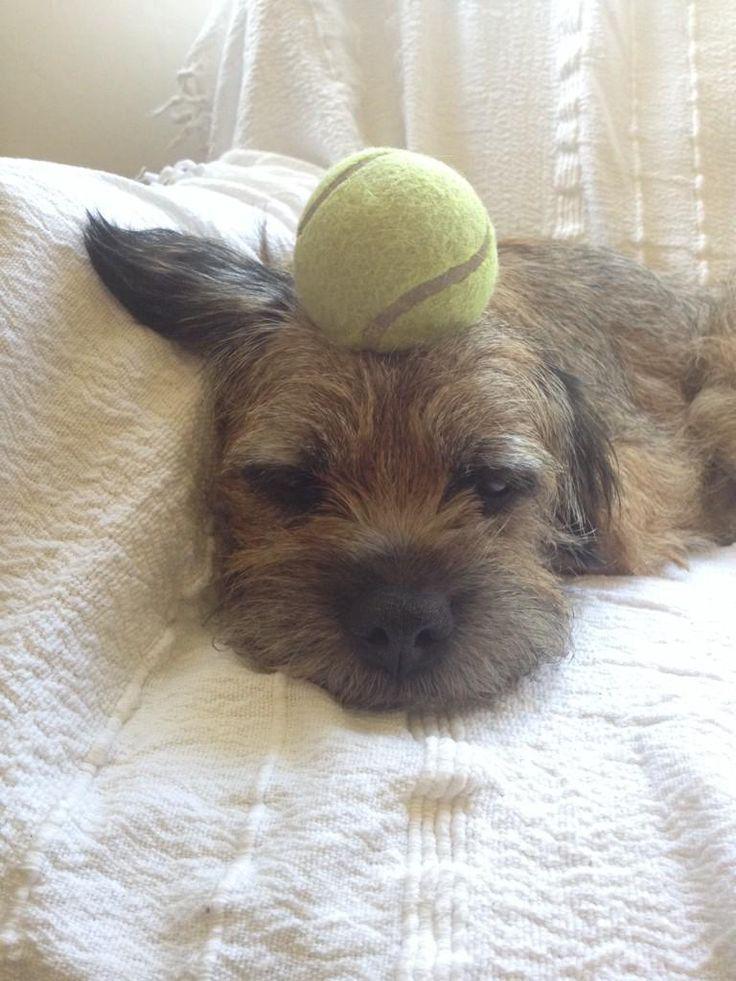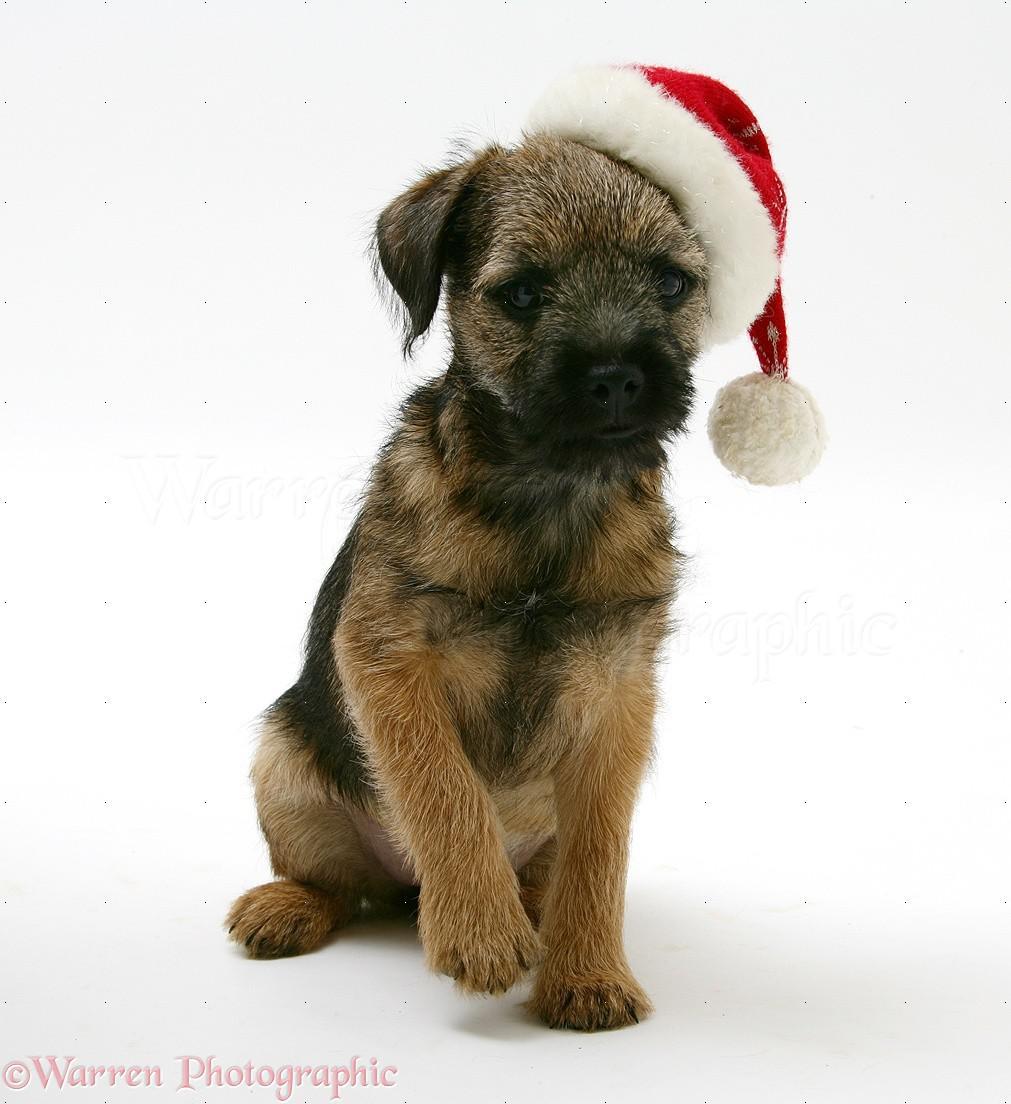The first image is the image on the left, the second image is the image on the right. Analyze the images presented: Is the assertion "the dog has a hat with a brim in the right side pic" valid? Answer yes or no. No. The first image is the image on the left, the second image is the image on the right. Assess this claim about the two images: "The dog in the image on the right is wearing a hat with a black band around the crown.". Correct or not? Answer yes or no. No. 